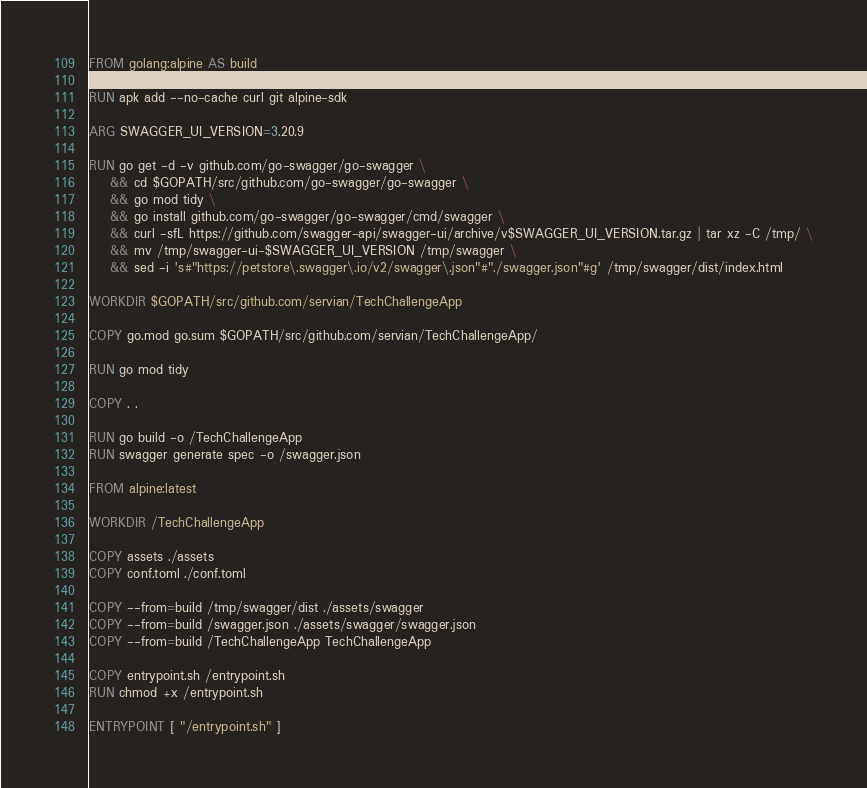<code> <loc_0><loc_0><loc_500><loc_500><_Dockerfile_>FROM golang:alpine AS build

RUN apk add --no-cache curl git alpine-sdk

ARG SWAGGER_UI_VERSION=3.20.9

RUN go get -d -v github.com/go-swagger/go-swagger \
    && cd $GOPATH/src/github.com/go-swagger/go-swagger \
    && go mod tidy \
    && go install github.com/go-swagger/go-swagger/cmd/swagger \
    && curl -sfL https://github.com/swagger-api/swagger-ui/archive/v$SWAGGER_UI_VERSION.tar.gz | tar xz -C /tmp/ \
    && mv /tmp/swagger-ui-$SWAGGER_UI_VERSION /tmp/swagger \
    && sed -i 's#"https://petstore\.swagger\.io/v2/swagger\.json"#"./swagger.json"#g' /tmp/swagger/dist/index.html

WORKDIR $GOPATH/src/github.com/servian/TechChallengeApp

COPY go.mod go.sum $GOPATH/src/github.com/servian/TechChallengeApp/

RUN go mod tidy

COPY . .

RUN go build -o /TechChallengeApp
RUN swagger generate spec -o /swagger.json

FROM alpine:latest

WORKDIR /TechChallengeApp

COPY assets ./assets
COPY conf.toml ./conf.toml

COPY --from=build /tmp/swagger/dist ./assets/swagger
COPY --from=build /swagger.json ./assets/swagger/swagger.json
COPY --from=build /TechChallengeApp TechChallengeApp

COPY entrypoint.sh /entrypoint.sh
RUN chmod +x /entrypoint.sh

ENTRYPOINT [ "/entrypoint.sh" ]</code> 